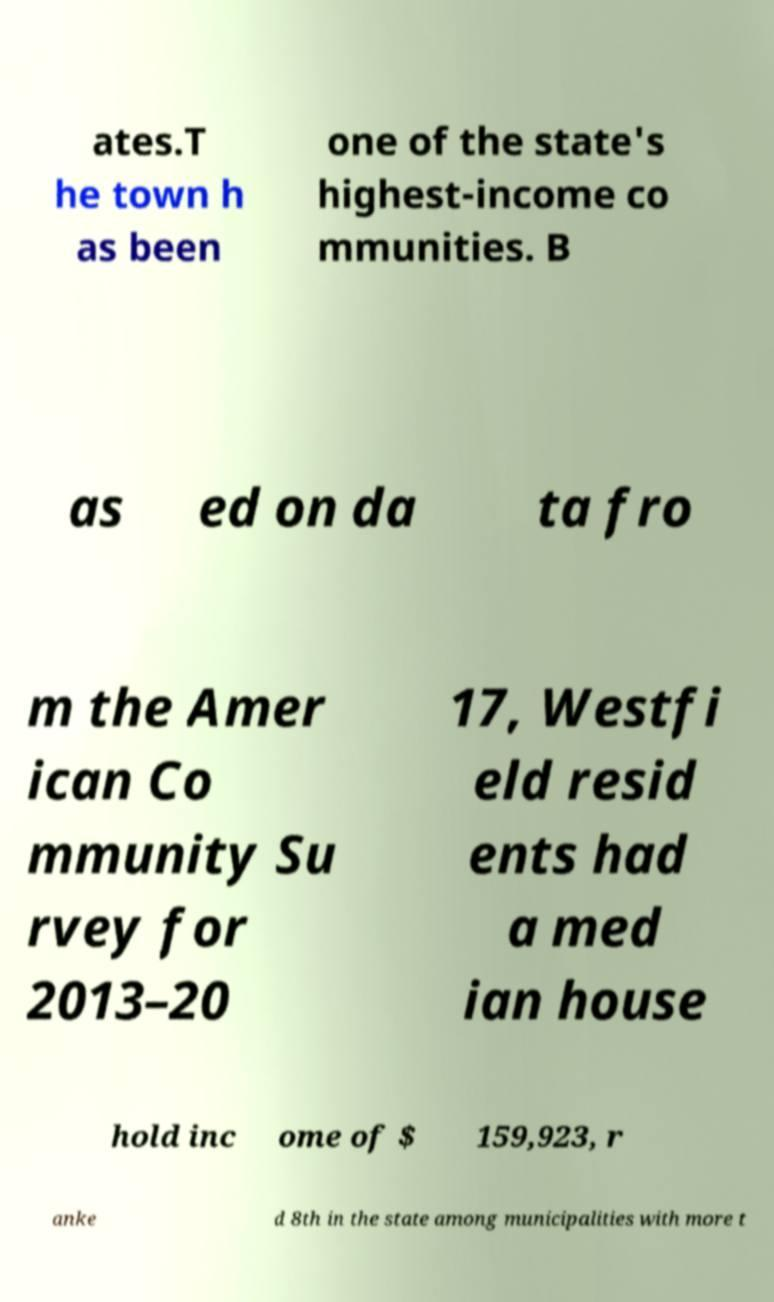Could you extract and type out the text from this image? ates.T he town h as been one of the state's highest-income co mmunities. B as ed on da ta fro m the Amer ican Co mmunity Su rvey for 2013–20 17, Westfi eld resid ents had a med ian house hold inc ome of $ 159,923, r anke d 8th in the state among municipalities with more t 